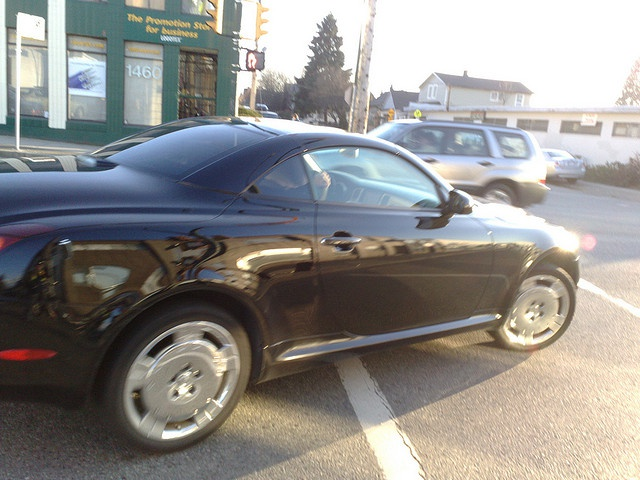Describe the objects in this image and their specific colors. I can see car in ivory, black, gray, and darkgray tones, car in ivory, lightgray, darkgray, lightblue, and gray tones, people in ivory, gray, and darkgray tones, car in ivory, lavender, and darkgray tones, and people in darkgray, gray, and ivory tones in this image. 